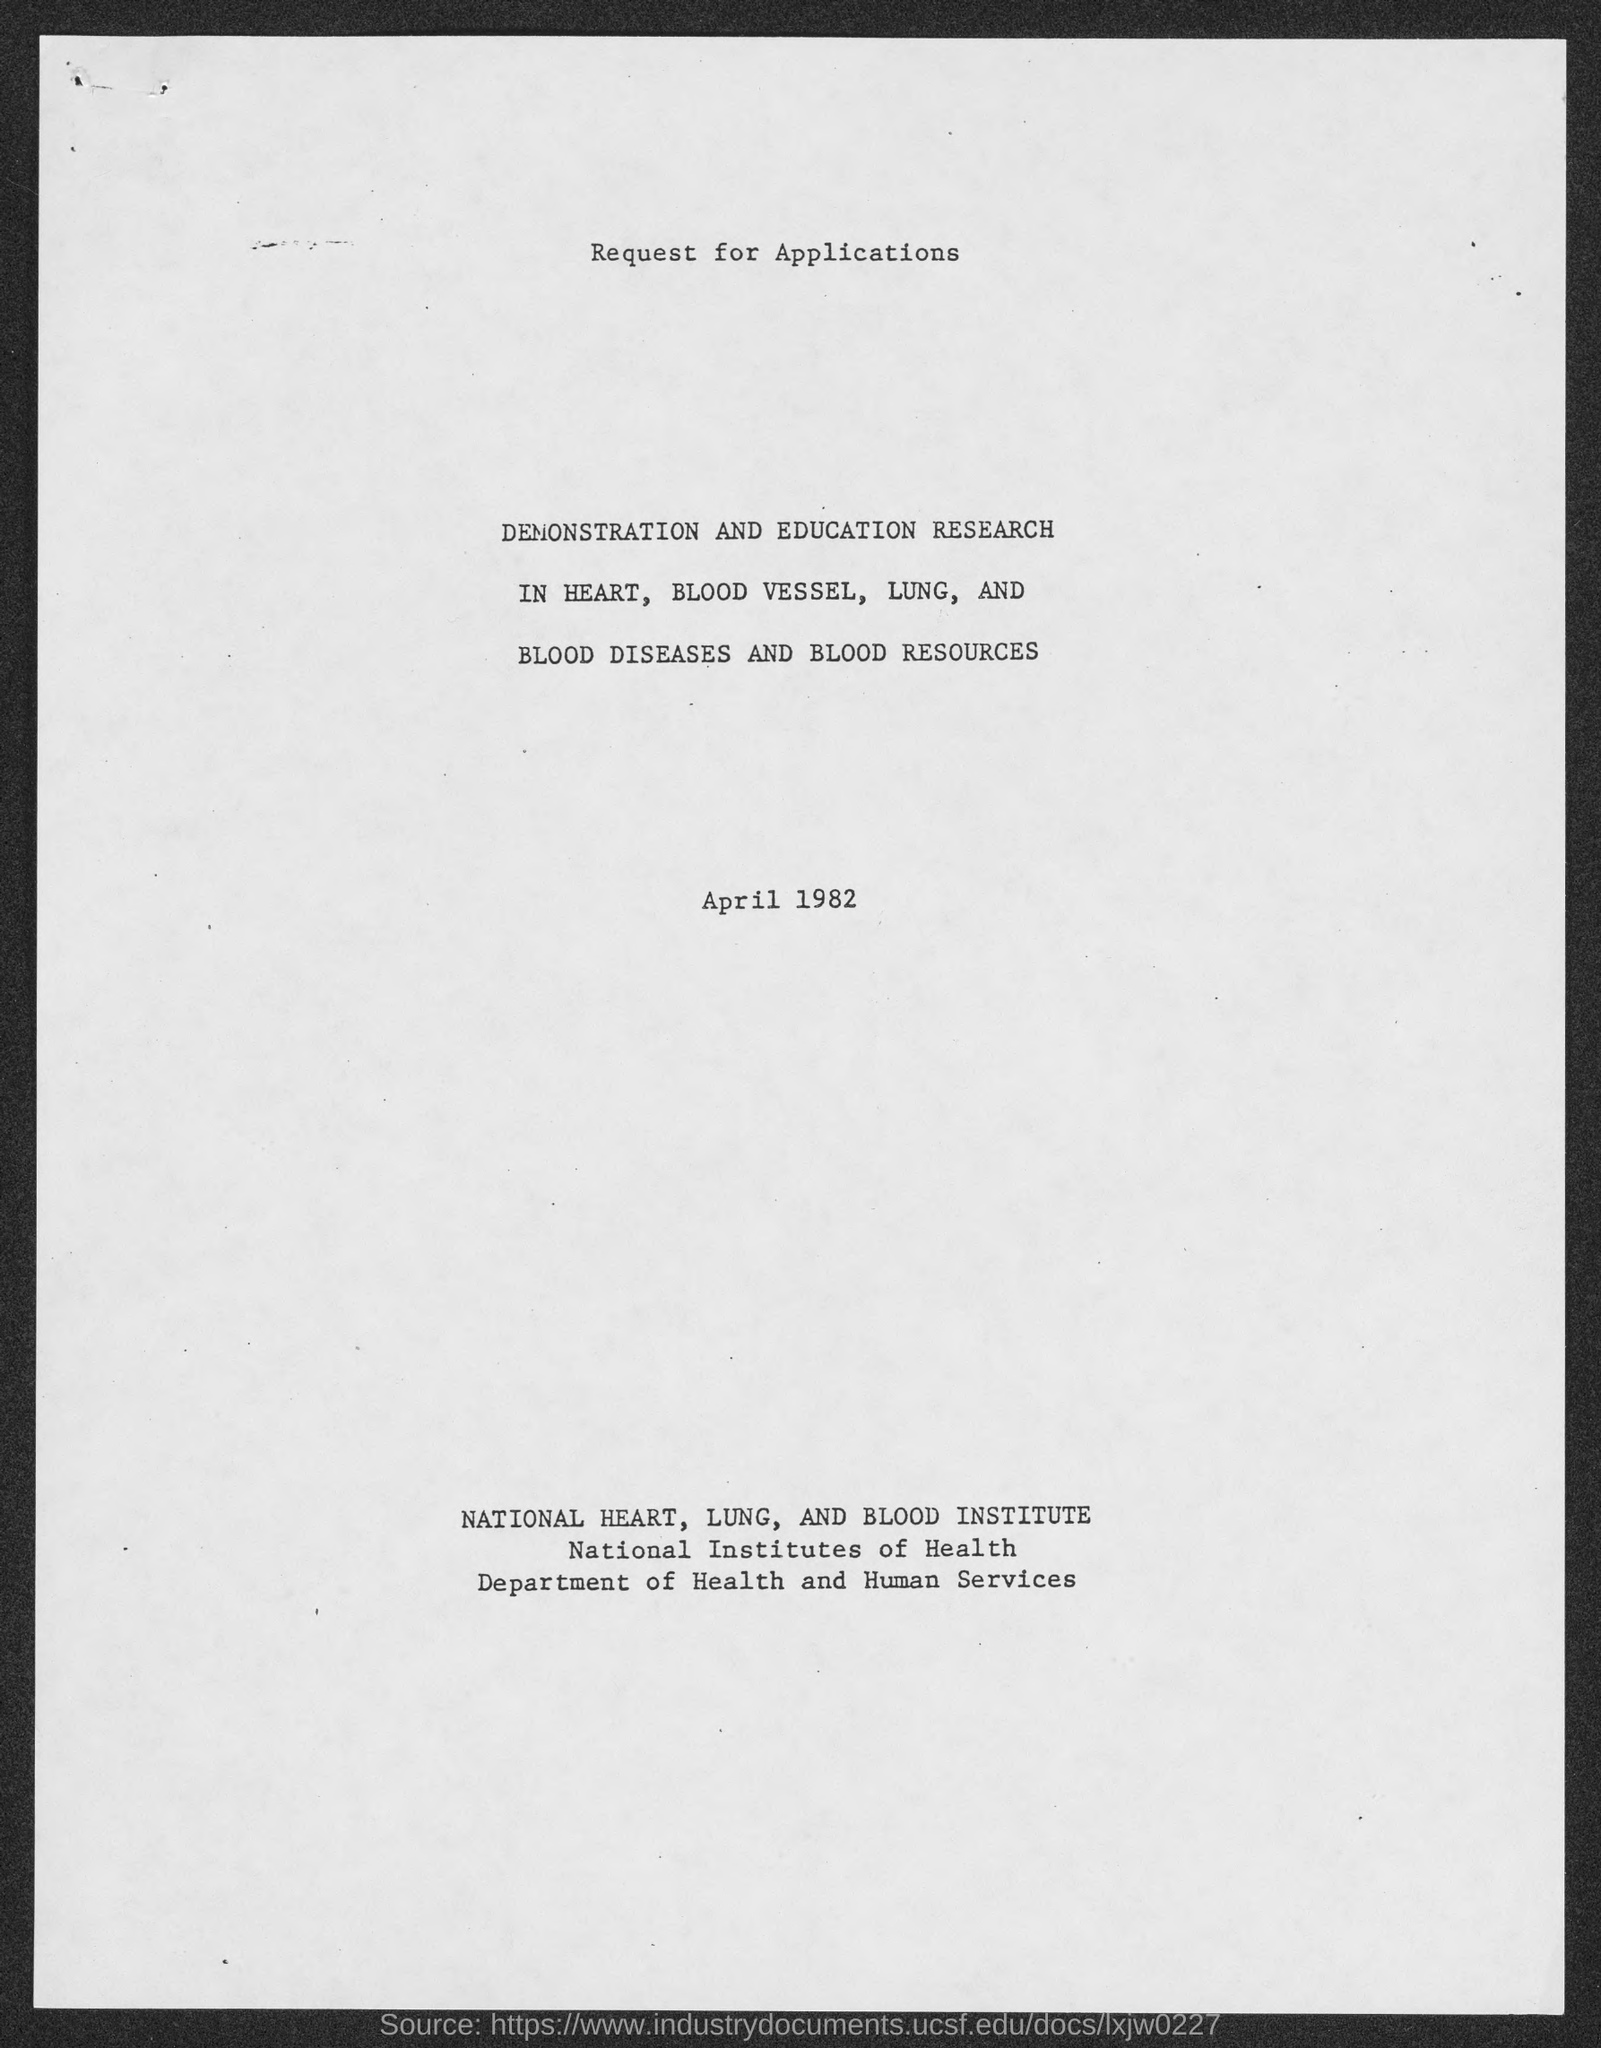When is the document dated?
Make the answer very short. April 1982. Which department is mentioned?
Offer a very short reply. Health and Human Services. 